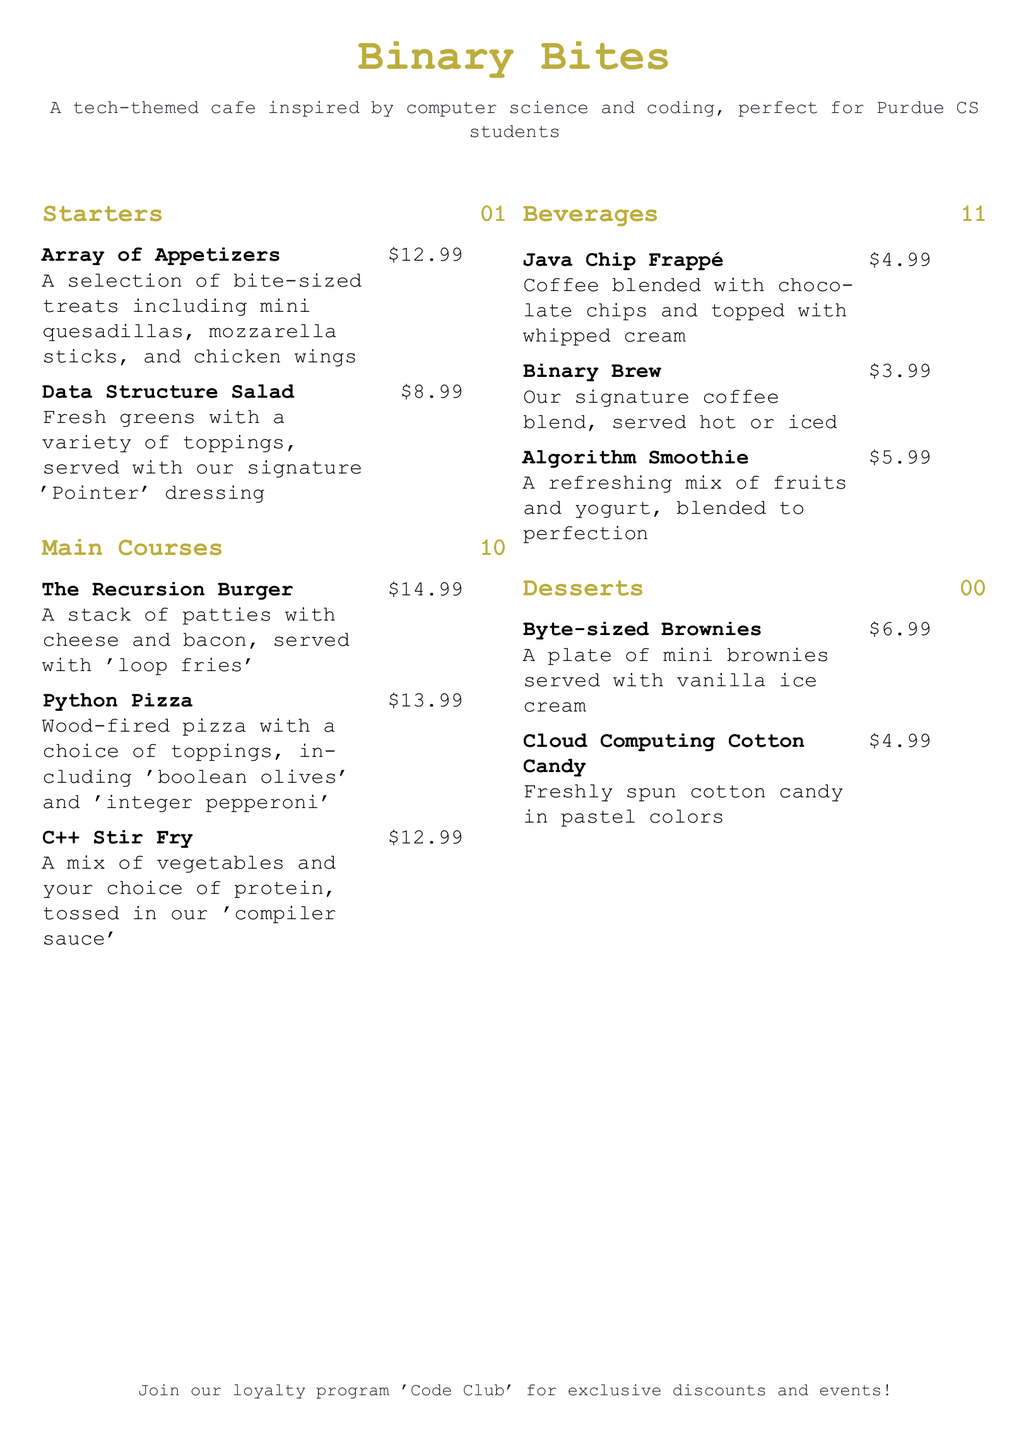What is the name of the cafe? The cafe is called "Binary Bites" as stated at the top of the menu.
Answer: Binary Bites What dish is priced at $8.99? The dish priced at $8.99 is "Data Structure Salad" listed under the Starters section.
Answer: Data Structure Salad What is the price of "The Recursion Burger"? The price of "The Recursion Burger" is $14.99 as mentioned in the Main Courses section.
Answer: $14.99 Which beverage is described as "Our signature coffee blend, served hot or iced"? The beverage described as such is "Binary Brew" which can be found in the Beverages section.
Answer: Binary Brew How many items are listed under Desserts? There are two items listed under Desserts, which are "Byte-sized Brownies" and "Cloud Computing Cotton Candy."
Answer: 2 What is the theme of the cafe menu? The theme of the cafe menu is inspired by computer science and coding, as indicated in the introduction.
Answer: Tech-themed What is included with the "Byte-sized Brownies"? The "Byte-sized Brownies" are served with vanilla ice cream, as specified in the Desserts section.
Answer: Vanilla ice cream Which dish features a mix of proteins and vegetables? The dish that features a mix of proteins and vegetables is "C++ Stir Fry" found in the Main Courses section.
Answer: C++ Stir Fry What is the loyalty program called? The loyalty program is referred to as "Code Club" in the footer of the menu.
Answer: Code Club 